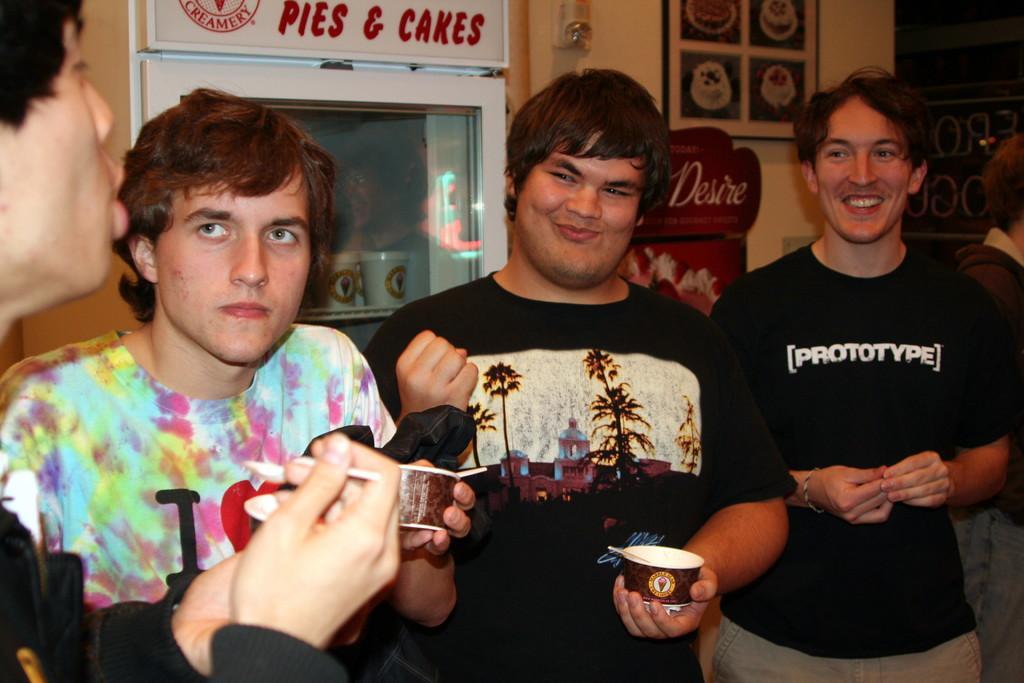Please provide a concise description of this image. As we can see in the image there is wall, window and photo frame. In the front there are four persons standing. The two persons standing on the right side are wearing black color t shirts. The three persons standing on the left side are holding paper cups. 